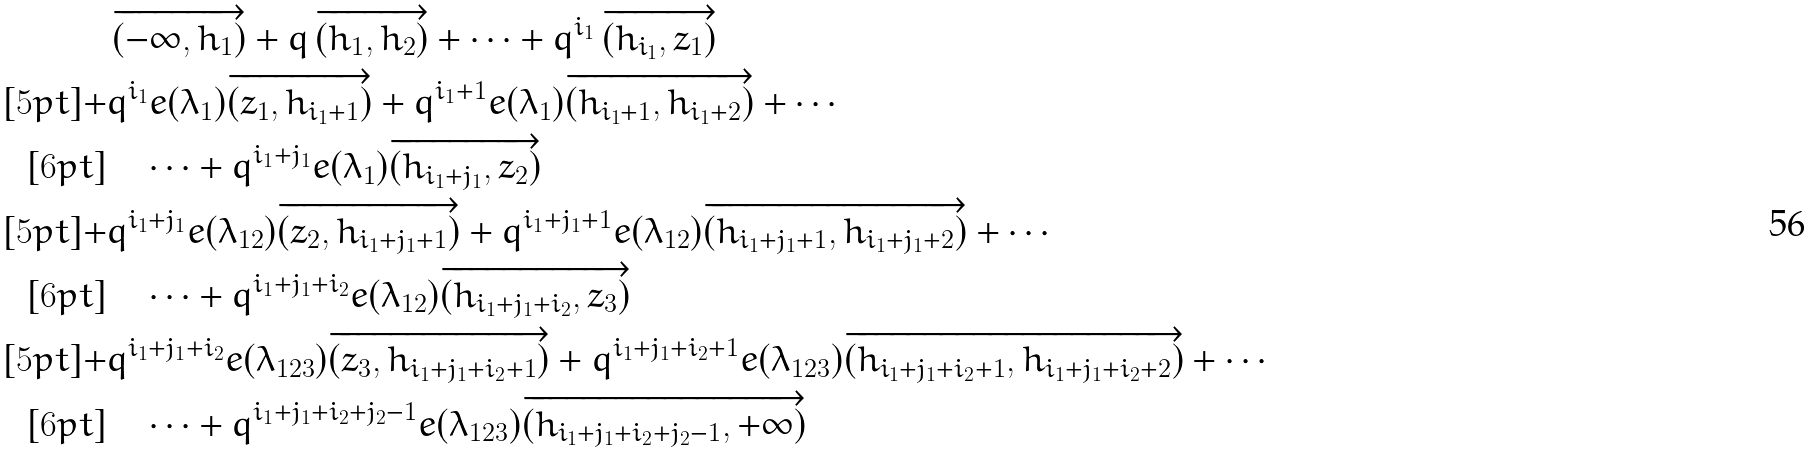Convert formula to latex. <formula><loc_0><loc_0><loc_500><loc_500>& \, \overrightarrow { ( - \infty , h _ { 1 } ) } + q \, \overrightarrow { ( h _ { 1 } , h _ { 2 } ) } + \cdots + q ^ { i _ { 1 } } \, \overrightarrow { ( h _ { i _ { 1 } } , z _ { 1 } ) } \\ [ 5 p t ] + & q ^ { i _ { 1 } } e ( \lambda _ { 1 } ) \overrightarrow { ( z _ { 1 } , h _ { i _ { 1 } + 1 } ) } + q ^ { i _ { 1 } + 1 } e ( \lambda _ { 1 } ) \overrightarrow { ( h _ { i _ { 1 } + 1 } , h _ { i _ { 1 } + 2 } ) } + \cdots \\ [ 6 p t ] & \quad \cdots + q ^ { i _ { 1 } + j _ { 1 } } e ( \lambda _ { 1 } ) \overrightarrow { ( h _ { i _ { 1 } + j _ { 1 } } , z _ { 2 } ) } \\ [ 5 p t ] + & q ^ { i _ { 1 } + j _ { 1 } } e ( \lambda _ { 1 2 } ) \overrightarrow { ( z _ { 2 } , h _ { i _ { 1 } + j _ { 1 } + 1 } ) } + q ^ { i _ { 1 } + j _ { 1 } + 1 } e ( \lambda _ { 1 2 } ) \overrightarrow { ( h _ { i _ { 1 } + j _ { 1 } + 1 } , h _ { i _ { 1 } + j _ { 1 } + 2 } ) } + \cdots \\ [ 6 p t ] & \quad \cdots + q ^ { i _ { 1 } + j _ { 1 } + i _ { 2 } } e ( \lambda _ { 1 2 } ) \overrightarrow { ( h _ { i _ { 1 } + j _ { 1 } + i _ { 2 } } , z _ { 3 } ) } \\ [ 5 p t ] + & q ^ { i _ { 1 } + j _ { 1 } + i _ { 2 } } e ( \lambda _ { 1 2 3 } ) \overrightarrow { ( z _ { 3 } , h _ { i _ { 1 } + j _ { 1 } + i _ { 2 } + 1 } ) } + q ^ { i _ { 1 } + j _ { 1 } + i _ { 2 } + 1 } e ( \lambda _ { 1 2 3 } ) \overrightarrow { ( h _ { i _ { 1 } + j _ { 1 } + i _ { 2 } + 1 } , h _ { i _ { 1 } + j _ { 1 } + i _ { 2 } + 2 } ) } + \cdots \\ [ 6 p t ] & \quad \cdots + q ^ { i _ { 1 } + j _ { 1 } + i _ { 2 } + j _ { 2 } - 1 } e ( \lambda _ { 1 2 3 } ) \overrightarrow { ( h _ { i _ { 1 } + j _ { 1 } + i _ { 2 } + j _ { 2 } - 1 } , + \infty ) }</formula> 